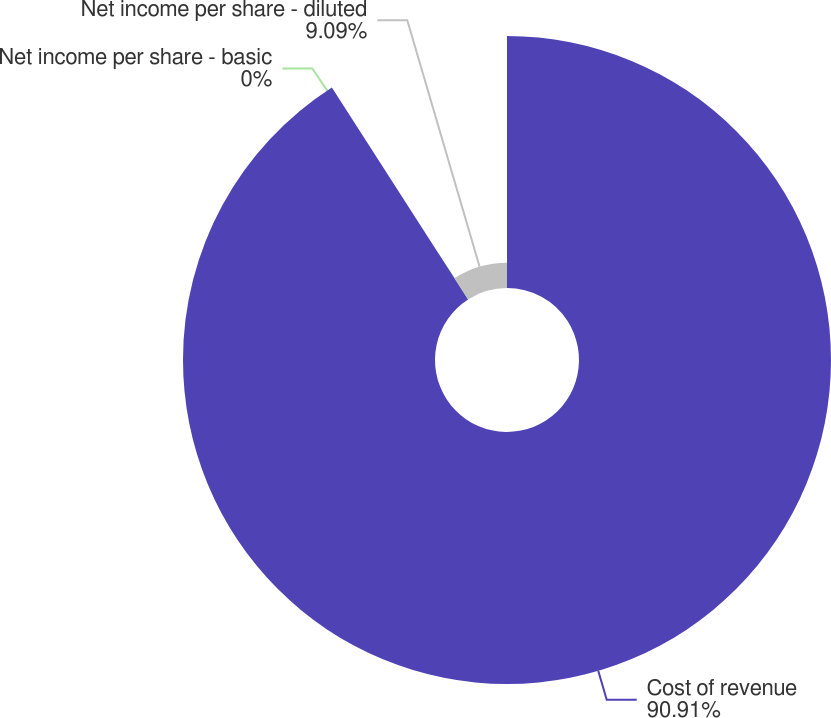Convert chart to OTSL. <chart><loc_0><loc_0><loc_500><loc_500><pie_chart><fcel>Cost of revenue<fcel>Net income per share - basic<fcel>Net income per share - diluted<nl><fcel>90.91%<fcel>0.0%<fcel>9.09%<nl></chart> 